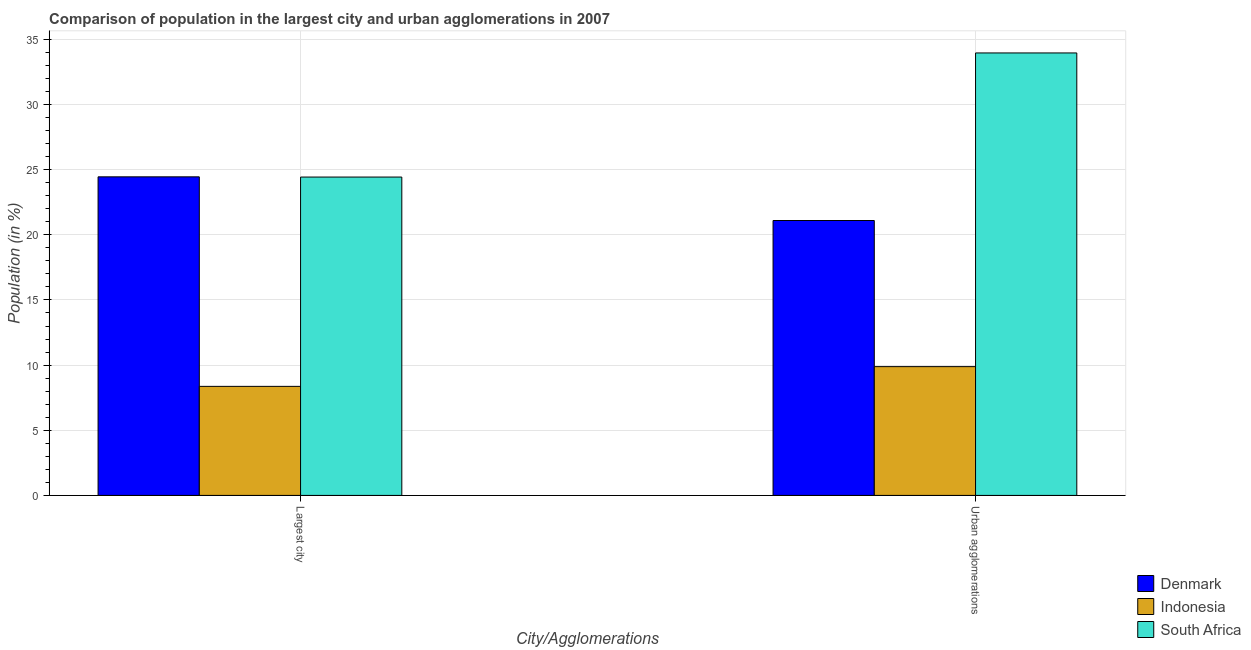How many different coloured bars are there?
Offer a very short reply. 3. How many groups of bars are there?
Your answer should be very brief. 2. Are the number of bars on each tick of the X-axis equal?
Provide a short and direct response. Yes. How many bars are there on the 1st tick from the left?
Your answer should be compact. 3. What is the label of the 1st group of bars from the left?
Ensure brevity in your answer.  Largest city. What is the population in urban agglomerations in Denmark?
Provide a short and direct response. 21.1. Across all countries, what is the maximum population in the largest city?
Your answer should be compact. 24.45. Across all countries, what is the minimum population in urban agglomerations?
Keep it short and to the point. 9.88. In which country was the population in urban agglomerations minimum?
Provide a short and direct response. Indonesia. What is the total population in urban agglomerations in the graph?
Your answer should be compact. 64.94. What is the difference between the population in the largest city in South Africa and that in Indonesia?
Your answer should be very brief. 16.06. What is the difference between the population in the largest city in Denmark and the population in urban agglomerations in Indonesia?
Your answer should be compact. 14.57. What is the average population in the largest city per country?
Provide a short and direct response. 19.08. What is the difference between the population in urban agglomerations and population in the largest city in South Africa?
Make the answer very short. 9.52. What is the ratio of the population in urban agglomerations in South Africa to that in Indonesia?
Your answer should be compact. 3.44. In how many countries, is the population in the largest city greater than the average population in the largest city taken over all countries?
Your answer should be very brief. 2. Does the graph contain grids?
Offer a terse response. Yes. How many legend labels are there?
Provide a succinct answer. 3. What is the title of the graph?
Keep it short and to the point. Comparison of population in the largest city and urban agglomerations in 2007. Does "Netherlands" appear as one of the legend labels in the graph?
Give a very brief answer. No. What is the label or title of the X-axis?
Your answer should be very brief. City/Agglomerations. What is the Population (in %) in Denmark in Largest city?
Offer a terse response. 24.45. What is the Population (in %) of Indonesia in Largest city?
Offer a very short reply. 8.37. What is the Population (in %) in South Africa in Largest city?
Keep it short and to the point. 24.43. What is the Population (in %) in Denmark in Urban agglomerations?
Your response must be concise. 21.1. What is the Population (in %) of Indonesia in Urban agglomerations?
Your response must be concise. 9.88. What is the Population (in %) of South Africa in Urban agglomerations?
Provide a succinct answer. 33.96. Across all City/Agglomerations, what is the maximum Population (in %) in Denmark?
Provide a short and direct response. 24.45. Across all City/Agglomerations, what is the maximum Population (in %) in Indonesia?
Make the answer very short. 9.88. Across all City/Agglomerations, what is the maximum Population (in %) of South Africa?
Your response must be concise. 33.96. Across all City/Agglomerations, what is the minimum Population (in %) in Denmark?
Provide a succinct answer. 21.1. Across all City/Agglomerations, what is the minimum Population (in %) of Indonesia?
Provide a succinct answer. 8.37. Across all City/Agglomerations, what is the minimum Population (in %) of South Africa?
Ensure brevity in your answer.  24.43. What is the total Population (in %) of Denmark in the graph?
Make the answer very short. 45.55. What is the total Population (in %) in Indonesia in the graph?
Ensure brevity in your answer.  18.25. What is the total Population (in %) of South Africa in the graph?
Provide a succinct answer. 58.39. What is the difference between the Population (in %) in Denmark in Largest city and that in Urban agglomerations?
Keep it short and to the point. 3.35. What is the difference between the Population (in %) of Indonesia in Largest city and that in Urban agglomerations?
Offer a very short reply. -1.51. What is the difference between the Population (in %) of South Africa in Largest city and that in Urban agglomerations?
Your answer should be very brief. -9.52. What is the difference between the Population (in %) of Denmark in Largest city and the Population (in %) of Indonesia in Urban agglomerations?
Your answer should be very brief. 14.57. What is the difference between the Population (in %) of Denmark in Largest city and the Population (in %) of South Africa in Urban agglomerations?
Your answer should be compact. -9.51. What is the difference between the Population (in %) in Indonesia in Largest city and the Population (in %) in South Africa in Urban agglomerations?
Offer a terse response. -25.59. What is the average Population (in %) in Denmark per City/Agglomerations?
Offer a very short reply. 22.77. What is the average Population (in %) in Indonesia per City/Agglomerations?
Provide a succinct answer. 9.13. What is the average Population (in %) of South Africa per City/Agglomerations?
Make the answer very short. 29.2. What is the difference between the Population (in %) in Denmark and Population (in %) in Indonesia in Largest city?
Provide a succinct answer. 16.08. What is the difference between the Population (in %) of Denmark and Population (in %) of South Africa in Largest city?
Your response must be concise. 0.02. What is the difference between the Population (in %) in Indonesia and Population (in %) in South Africa in Largest city?
Your response must be concise. -16.06. What is the difference between the Population (in %) of Denmark and Population (in %) of Indonesia in Urban agglomerations?
Your answer should be compact. 11.22. What is the difference between the Population (in %) of Denmark and Population (in %) of South Africa in Urban agglomerations?
Ensure brevity in your answer.  -12.86. What is the difference between the Population (in %) of Indonesia and Population (in %) of South Africa in Urban agglomerations?
Give a very brief answer. -24.07. What is the ratio of the Population (in %) in Denmark in Largest city to that in Urban agglomerations?
Offer a terse response. 1.16. What is the ratio of the Population (in %) in Indonesia in Largest city to that in Urban agglomerations?
Provide a short and direct response. 0.85. What is the ratio of the Population (in %) of South Africa in Largest city to that in Urban agglomerations?
Provide a succinct answer. 0.72. What is the difference between the highest and the second highest Population (in %) of Denmark?
Offer a terse response. 3.35. What is the difference between the highest and the second highest Population (in %) of Indonesia?
Make the answer very short. 1.51. What is the difference between the highest and the second highest Population (in %) of South Africa?
Give a very brief answer. 9.52. What is the difference between the highest and the lowest Population (in %) in Denmark?
Give a very brief answer. 3.35. What is the difference between the highest and the lowest Population (in %) of Indonesia?
Your answer should be very brief. 1.51. What is the difference between the highest and the lowest Population (in %) in South Africa?
Your answer should be very brief. 9.52. 